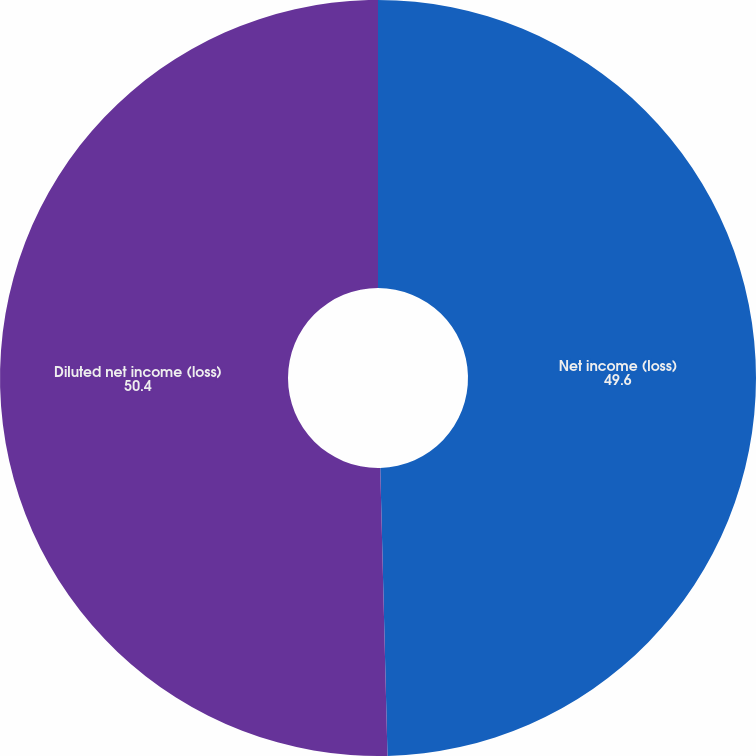Convert chart to OTSL. <chart><loc_0><loc_0><loc_500><loc_500><pie_chart><fcel>Net income (loss)<fcel>Diluted net income (loss)<nl><fcel>49.6%<fcel>50.4%<nl></chart> 